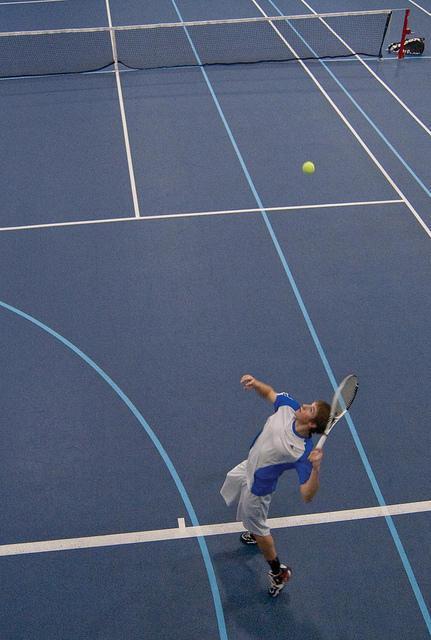How many mouse can you see?
Give a very brief answer. 0. 